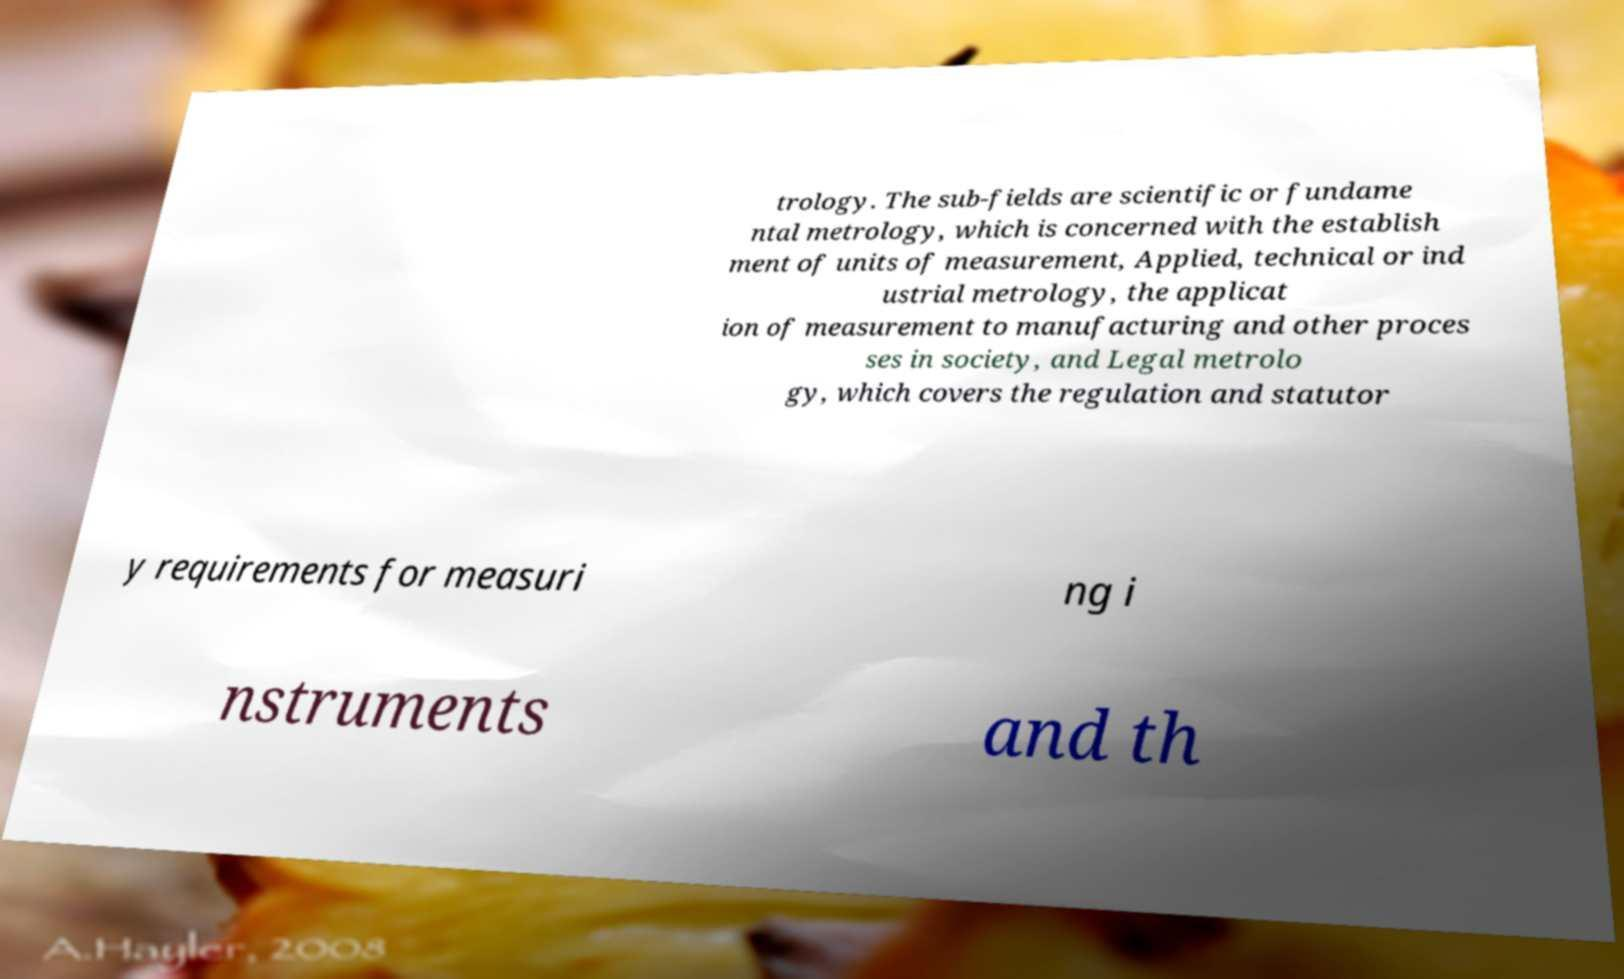Could you assist in decoding the text presented in this image and type it out clearly? trology. The sub-fields are scientific or fundame ntal metrology, which is concerned with the establish ment of units of measurement, Applied, technical or ind ustrial metrology, the applicat ion of measurement to manufacturing and other proces ses in society, and Legal metrolo gy, which covers the regulation and statutor y requirements for measuri ng i nstruments and th 